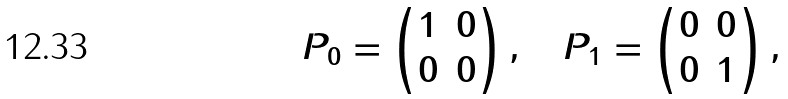<formula> <loc_0><loc_0><loc_500><loc_500>P _ { 0 } = \begin{pmatrix} 1 & 0 \\ 0 & 0 \end{pmatrix} , \quad P _ { 1 } = \begin{pmatrix} 0 & 0 \\ 0 & 1 \end{pmatrix} ,</formula> 